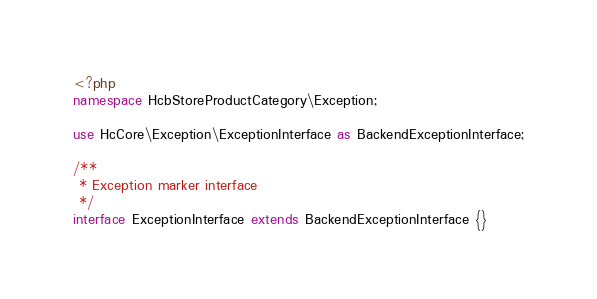<code> <loc_0><loc_0><loc_500><loc_500><_PHP_><?php
namespace HcbStoreProductCategory\Exception;

use HcCore\Exception\ExceptionInterface as BackendExceptionInterface;

/**
 * Exception marker interface
 */
interface ExceptionInterface extends BackendExceptionInterface {}
</code> 